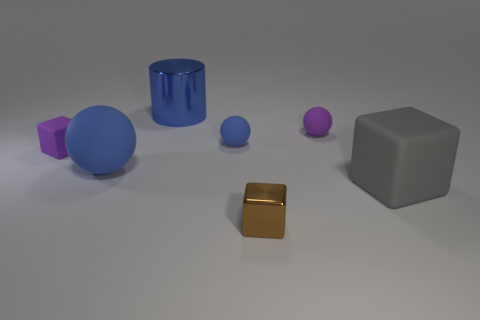Is there anything else that is the same color as the small metallic thing?
Your response must be concise. No. What size is the block that is on the left side of the large rubber cube and in front of the purple rubber block?
Make the answer very short. Small. There is a big matte thing to the left of the purple rubber ball; is it the same color as the block that is on the left side of the large blue cylinder?
Ensure brevity in your answer.  No. What number of other objects are there of the same material as the small brown object?
Offer a very short reply. 1. What is the shape of the matte object that is both behind the large blue rubber thing and to the left of the blue cylinder?
Your answer should be very brief. Cube. Do the cylinder and the large rubber object to the left of the small shiny cube have the same color?
Your response must be concise. Yes. There is a rubber cube that is on the left side of the blue cylinder; does it have the same size as the big cube?
Your answer should be compact. No. There is a large object that is the same shape as the tiny shiny object; what is its material?
Offer a terse response. Rubber. Do the gray object and the tiny brown thing have the same shape?
Give a very brief answer. Yes. There is a metallic object that is on the right side of the blue shiny cylinder; what number of blue matte things are to the left of it?
Ensure brevity in your answer.  2. 